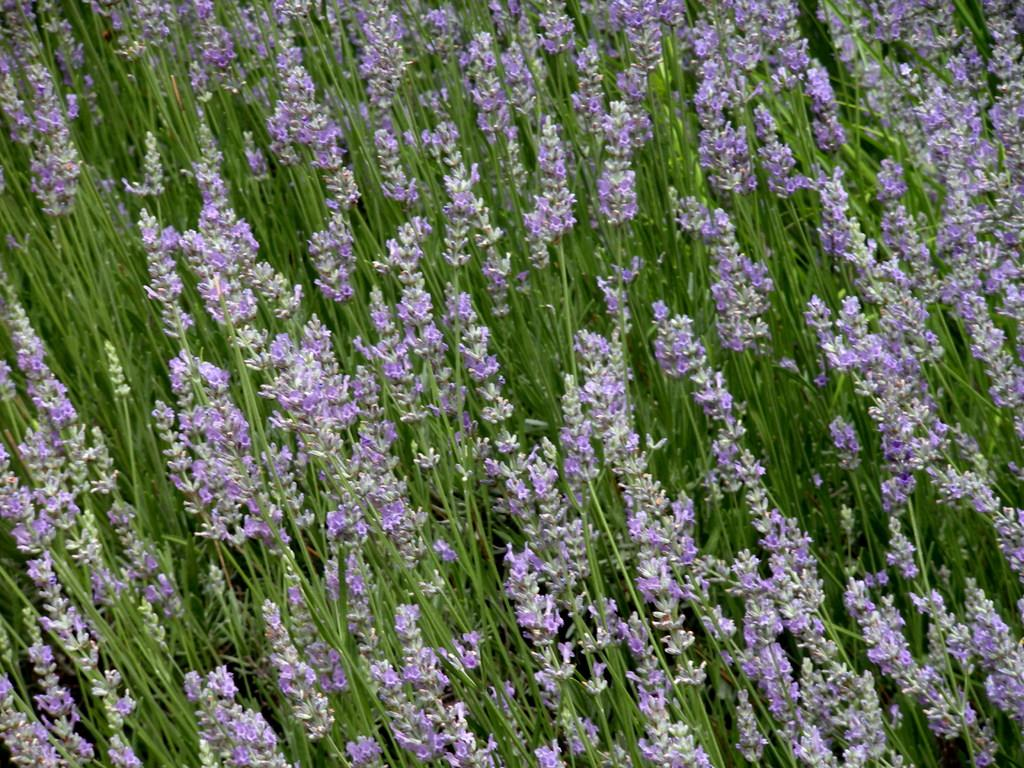What type of living organisms can be seen in the image? Plants can be seen in the image. What specific features are present on the plants? There are flowers on the plants. What color are the flowers? The flowers are in violet color. How many passengers are visible in the image? There are no passengers present in the image; it features plants with violet flowers. What type of flame can be seen in the image? There is no flame present in the image. 